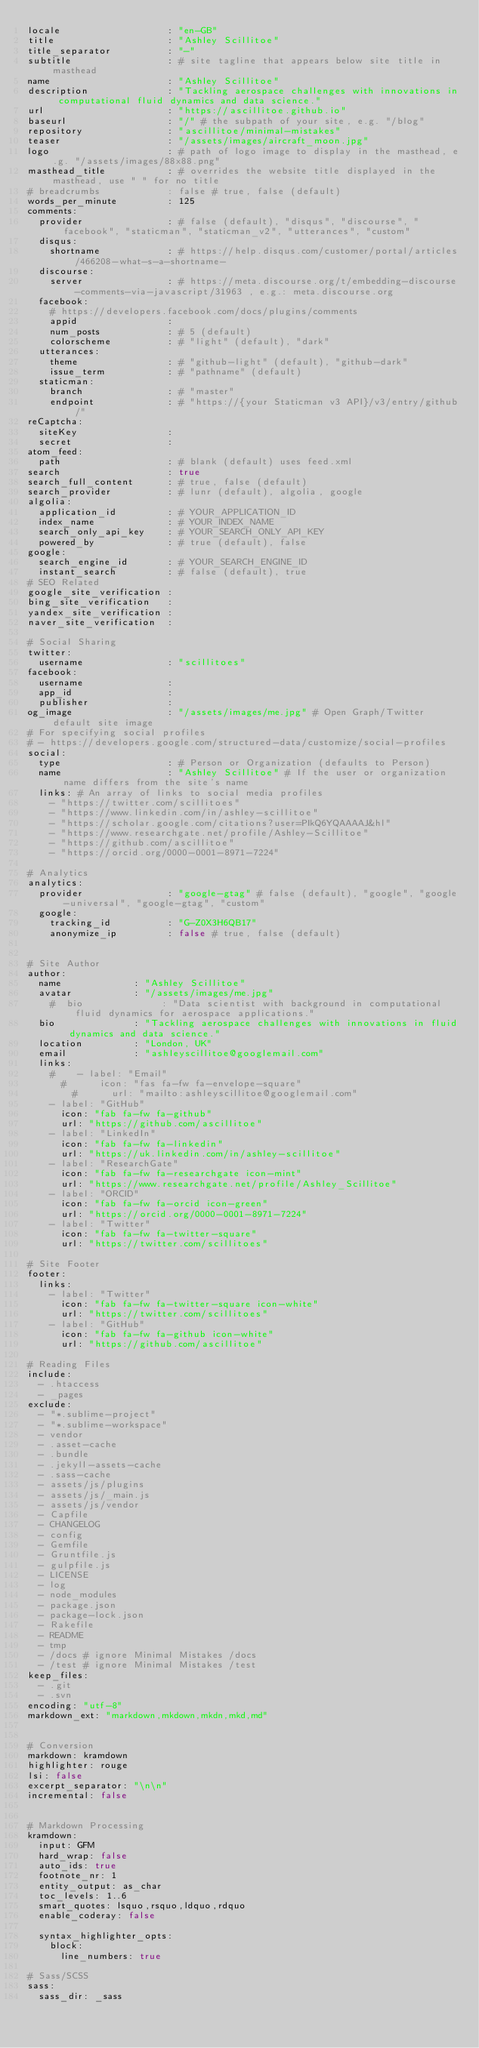Convert code to text. <code><loc_0><loc_0><loc_500><loc_500><_YAML_>locale                   : "en-GB"
title                    : "Ashley Scillitoe"
title_separator          : "-"
subtitle                 : # site tagline that appears below site title in masthead
name                     : "Ashley Scillitoe"
description              : "Tackling aerospace challenges with innovations in computational fluid dynamics and data science."
url                      : "https://ascillitoe.github.io"
baseurl                  : "/" # the subpath of your site, e.g. "/blog"
repository               : "ascillitoe/minimal-mistakes"
teaser                   : "/assets/images/aircraft_moon.jpg"
logo                     : # path of logo image to display in the masthead, e.g. "/assets/images/88x88.png"
masthead_title           : # overrides the website title displayed in the masthead, use " " for no title
# breadcrumbs            : false # true, false (default)
words_per_minute         : 125
comments:
  provider               : # false (default), "disqus", "discourse", "facebook", "staticman", "staticman_v2", "utterances", "custom"
  disqus:
    shortname            : # https://help.disqus.com/customer/portal/articles/466208-what-s-a-shortname-
  discourse:
    server               : # https://meta.discourse.org/t/embedding-discourse-comments-via-javascript/31963 , e.g.: meta.discourse.org
  facebook:
    # https://developers.facebook.com/docs/plugins/comments
    appid                :
    num_posts            : # 5 (default)
    colorscheme          : # "light" (default), "dark"
  utterances:
    theme                : # "github-light" (default), "github-dark"
    issue_term           : # "pathname" (default)
  staticman:
    branch               : # "master"
    endpoint             : # "https://{your Staticman v3 API}/v3/entry/github/"
reCaptcha:
  siteKey                :
  secret                 :
atom_feed:
  path                   : # blank (default) uses feed.xml
search                   : true
search_full_content      : # true, false (default)
search_provider          : # lunr (default), algolia, google
algolia:
  application_id         : # YOUR_APPLICATION_ID
  index_name             : # YOUR_INDEX_NAME
  search_only_api_key    : # YOUR_SEARCH_ONLY_API_KEY
  powered_by             : # true (default), false
google:
  search_engine_id       : # YOUR_SEARCH_ENGINE_ID
  instant_search         : # false (default), true
# SEO Related
google_site_verification :
bing_site_verification   :
yandex_site_verification :
naver_site_verification  :

# Social Sharing
twitter:
  username               : "scillitoes"
facebook:
  username               :
  app_id                 :
  publisher              :
og_image                 : "/assets/images/me.jpg" # Open Graph/Twitter default site image
# For specifying social profiles
# - https://developers.google.com/structured-data/customize/social-profiles
social:
  type                   : # Person or Organization (defaults to Person)
  name                   : "Ashley Scillitoe" # If the user or organization name differs from the site's name
  links: # An array of links to social media profiles
    - "https://twitter.com/scillitoes"
    - "https://www.linkedin.com/in/ashley-scillitoe"
    - "https://scholar.google.com/citations?user=PIkQ6YQAAAAJ&hl"
    - "https://www.researchgate.net/profile/Ashley-Scillitoe"
    - "https://github.com/ascillitoe"
    - "https://orcid.org/0000-0001-8971-7224"

# Analytics
analytics:
  provider               : "google-gtag" # false (default), "google", "google-universal", "google-gtag", "custom"
  google:
    tracking_id          : "G-Z0X3H6QB17"
    anonymize_ip         : false # true, false (default)


# Site Author
author:
  name             : "Ashley Scillitoe"
  avatar           : "/assets/images/me.jpg"
    #  bio              : "Data scientist with background in computational fluid dynamics for aerospace applications."
  bio              : "Tackling aerospace challenges with innovations in fluid dynamics and data science."
  location         : "London, UK"
  email            : "ashleyscillitoe@googlemail.com"
  links:
    #    - label: "Email"
      #      icon: "fas fa-fw fa-envelope-square"
        #      url: "mailto:ashleyscillitoe@googlemail.com"
    - label: "GitHub"
      icon: "fab fa-fw fa-github"
      url: "https://github.com/ascillitoe"
    - label: "LinkedIn"
      icon: "fab fa-fw fa-linkedin"
      url: "https://uk.linkedin.com/in/ashley-scillitoe"
    - label: "ResearchGate"
      icon: "fab fa-fw fa-researchgate icon-mint"
      url: "https://www.researchgate.net/profile/Ashley_Scillitoe"
    - label: "ORCID"
      icon: "fab fa-fw fa-orcid icon-green"
      url: "https://orcid.org/0000-0001-8971-7224"
    - label: "Twitter"
      icon: "fab fa-fw fa-twitter-square"
      url: "https://twitter.com/scillitoes"

# Site Footer
footer:
  links:
    - label: "Twitter"
      icon: "fab fa-fw fa-twitter-square icon-white"
      url: "https://twitter.com/scillitoes"
    - label: "GitHub"
      icon: "fab fa-fw fa-github icon-white"
      url: "https://github.com/ascillitoe"

# Reading Files
include:
  - .htaccess
  - _pages
exclude:
  - "*.sublime-project"
  - "*.sublime-workspace"
  - vendor
  - .asset-cache
  - .bundle
  - .jekyll-assets-cache
  - .sass-cache
  - assets/js/plugins
  - assets/js/_main.js
  - assets/js/vendor
  - Capfile
  - CHANGELOG
  - config
  - Gemfile
  - Gruntfile.js
  - gulpfile.js
  - LICENSE
  - log
  - node_modules
  - package.json
  - package-lock.json
  - Rakefile
  - README
  - tmp
  - /docs # ignore Minimal Mistakes /docs
  - /test # ignore Minimal Mistakes /test
keep_files:
  - .git
  - .svn
encoding: "utf-8"
markdown_ext: "markdown,mkdown,mkdn,mkd,md"


# Conversion
markdown: kramdown
highlighter: rouge
lsi: false
excerpt_separator: "\n\n"
incremental: false


# Markdown Processing
kramdown:
  input: GFM
  hard_wrap: false
  auto_ids: true
  footnote_nr: 1
  entity_output: as_char
  toc_levels: 1..6
  smart_quotes: lsquo,rsquo,ldquo,rdquo
  enable_coderay: false

  syntax_highlighter_opts:
    block:
      line_numbers: true

# Sass/SCSS
sass:
  sass_dir: _sass</code> 